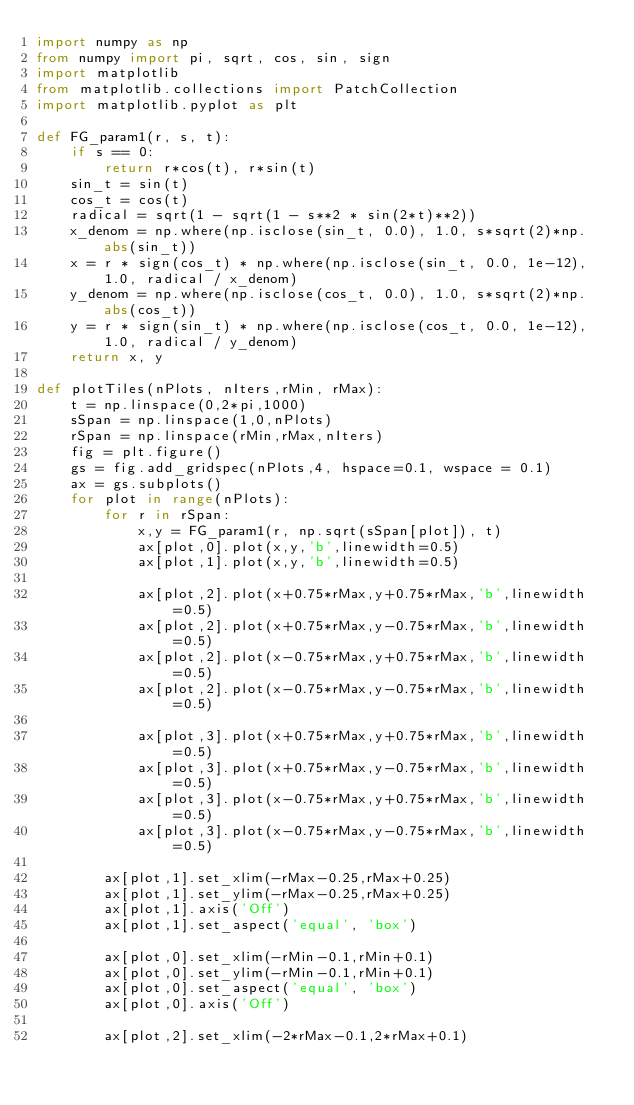Convert code to text. <code><loc_0><loc_0><loc_500><loc_500><_Python_>import numpy as np
from numpy import pi, sqrt, cos, sin, sign
import matplotlib
from matplotlib.collections import PatchCollection
import matplotlib.pyplot as plt

def FG_param1(r, s, t):
    if s == 0:
        return r*cos(t), r*sin(t)
    sin_t = sin(t)
    cos_t = cos(t)
    radical = sqrt(1 - sqrt(1 - s**2 * sin(2*t)**2))
    x_denom = np.where(np.isclose(sin_t, 0.0), 1.0, s*sqrt(2)*np.abs(sin_t))
    x = r * sign(cos_t) * np.where(np.isclose(sin_t, 0.0, 1e-12), 1.0, radical / x_denom)
    y_denom = np.where(np.isclose(cos_t, 0.0), 1.0, s*sqrt(2)*np.abs(cos_t))
    y = r * sign(sin_t) * np.where(np.isclose(cos_t, 0.0, 1e-12), 1.0, radical / y_denom)
    return x, y

def plotTiles(nPlots, nIters,rMin, rMax):
	t = np.linspace(0,2*pi,1000)
	sSpan = np.linspace(1,0,nPlots)
	rSpan = np.linspace(rMin,rMax,nIters)
	fig = plt.figure()
	gs = fig.add_gridspec(nPlots,4, hspace=0.1, wspace = 0.1)
	ax = gs.subplots()
	for plot in range(nPlots):
		for r in rSpan:
			x,y = FG_param1(r, np.sqrt(sSpan[plot]), t)
			ax[plot,0].plot(x,y,'b',linewidth=0.5)
			ax[plot,1].plot(x,y,'b',linewidth=0.5)

			ax[plot,2].plot(x+0.75*rMax,y+0.75*rMax,'b',linewidth=0.5)
			ax[plot,2].plot(x+0.75*rMax,y-0.75*rMax,'b',linewidth=0.5)
			ax[plot,2].plot(x-0.75*rMax,y+0.75*rMax,'b',linewidth=0.5)
			ax[plot,2].plot(x-0.75*rMax,y-0.75*rMax,'b',linewidth=0.5)

			ax[plot,3].plot(x+0.75*rMax,y+0.75*rMax,'b',linewidth=0.5)
			ax[plot,3].plot(x+0.75*rMax,y-0.75*rMax,'b',linewidth=0.5)
			ax[plot,3].plot(x-0.75*rMax,y+0.75*rMax,'b',linewidth=0.5)
			ax[plot,3].plot(x-0.75*rMax,y-0.75*rMax,'b',linewidth=0.5)
		
		ax[plot,1].set_xlim(-rMax-0.25,rMax+0.25)
		ax[plot,1].set_ylim(-rMax-0.25,rMax+0.25)
		ax[plot,1].axis('Off')
		ax[plot,1].set_aspect('equal', 'box')

		ax[plot,0].set_xlim(-rMin-0.1,rMin+0.1)
		ax[plot,0].set_ylim(-rMin-0.1,rMin+0.1)
		ax[plot,0].set_aspect('equal', 'box')
		ax[plot,0].axis('Off')

		ax[plot,2].set_xlim(-2*rMax-0.1,2*rMax+0.1)</code> 